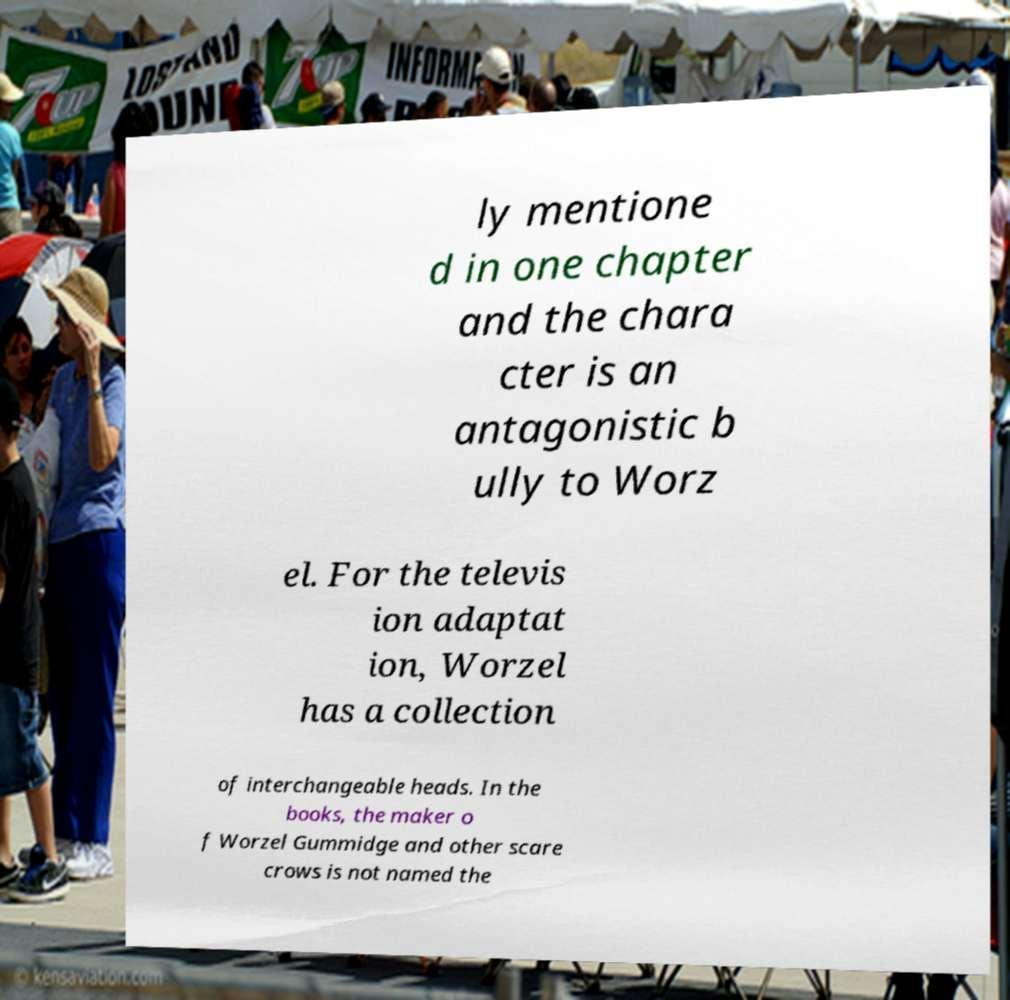For documentation purposes, I need the text within this image transcribed. Could you provide that? ly mentione d in one chapter and the chara cter is an antagonistic b ully to Worz el. For the televis ion adaptat ion, Worzel has a collection of interchangeable heads. In the books, the maker o f Worzel Gummidge and other scare crows is not named the 